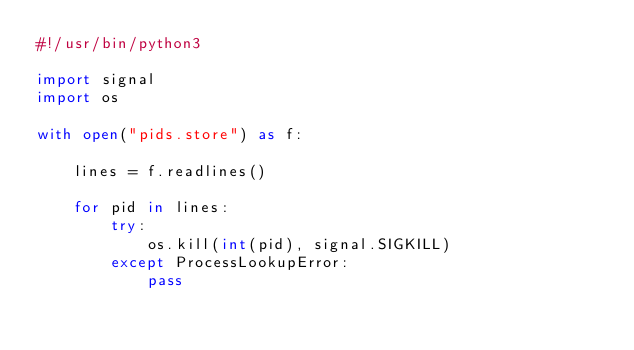Convert code to text. <code><loc_0><loc_0><loc_500><loc_500><_Python_>#!/usr/bin/python3

import signal
import os

with open("pids.store") as f:
    
    lines = f.readlines()
    
    for pid in lines:
        try:
            os.kill(int(pid), signal.SIGKILL)
        except ProcessLookupError:
            pass

</code> 